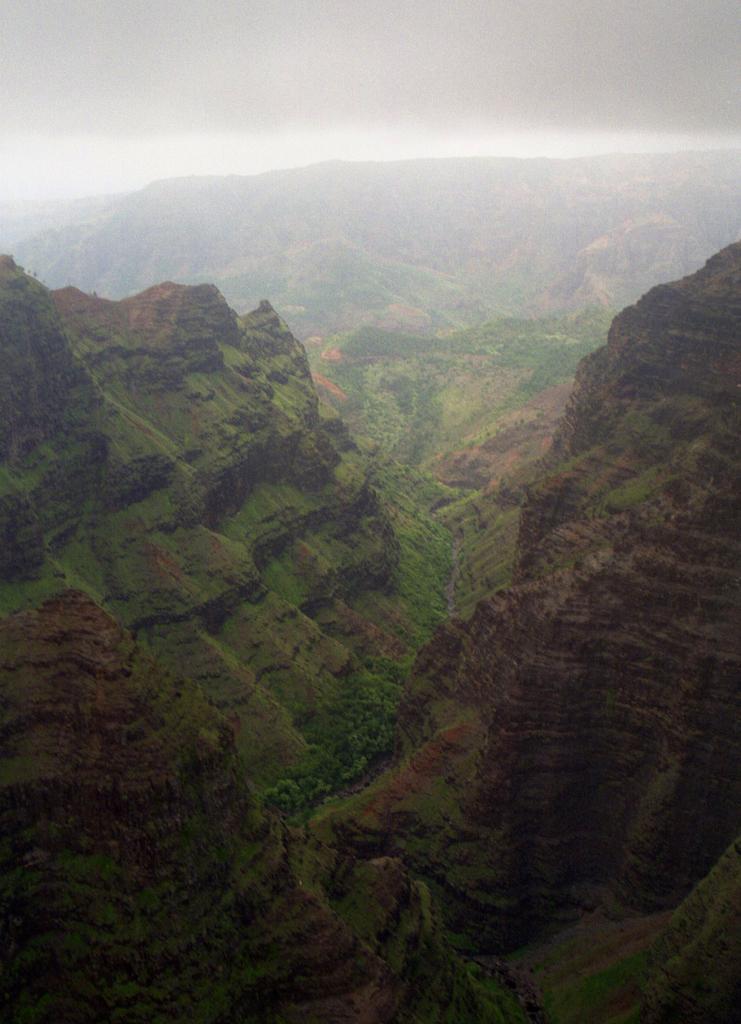Describe this image in one or two sentences. In this image we can see the mountains and in the middle we can see some trees. At the top, we can see the sky with clouds. 